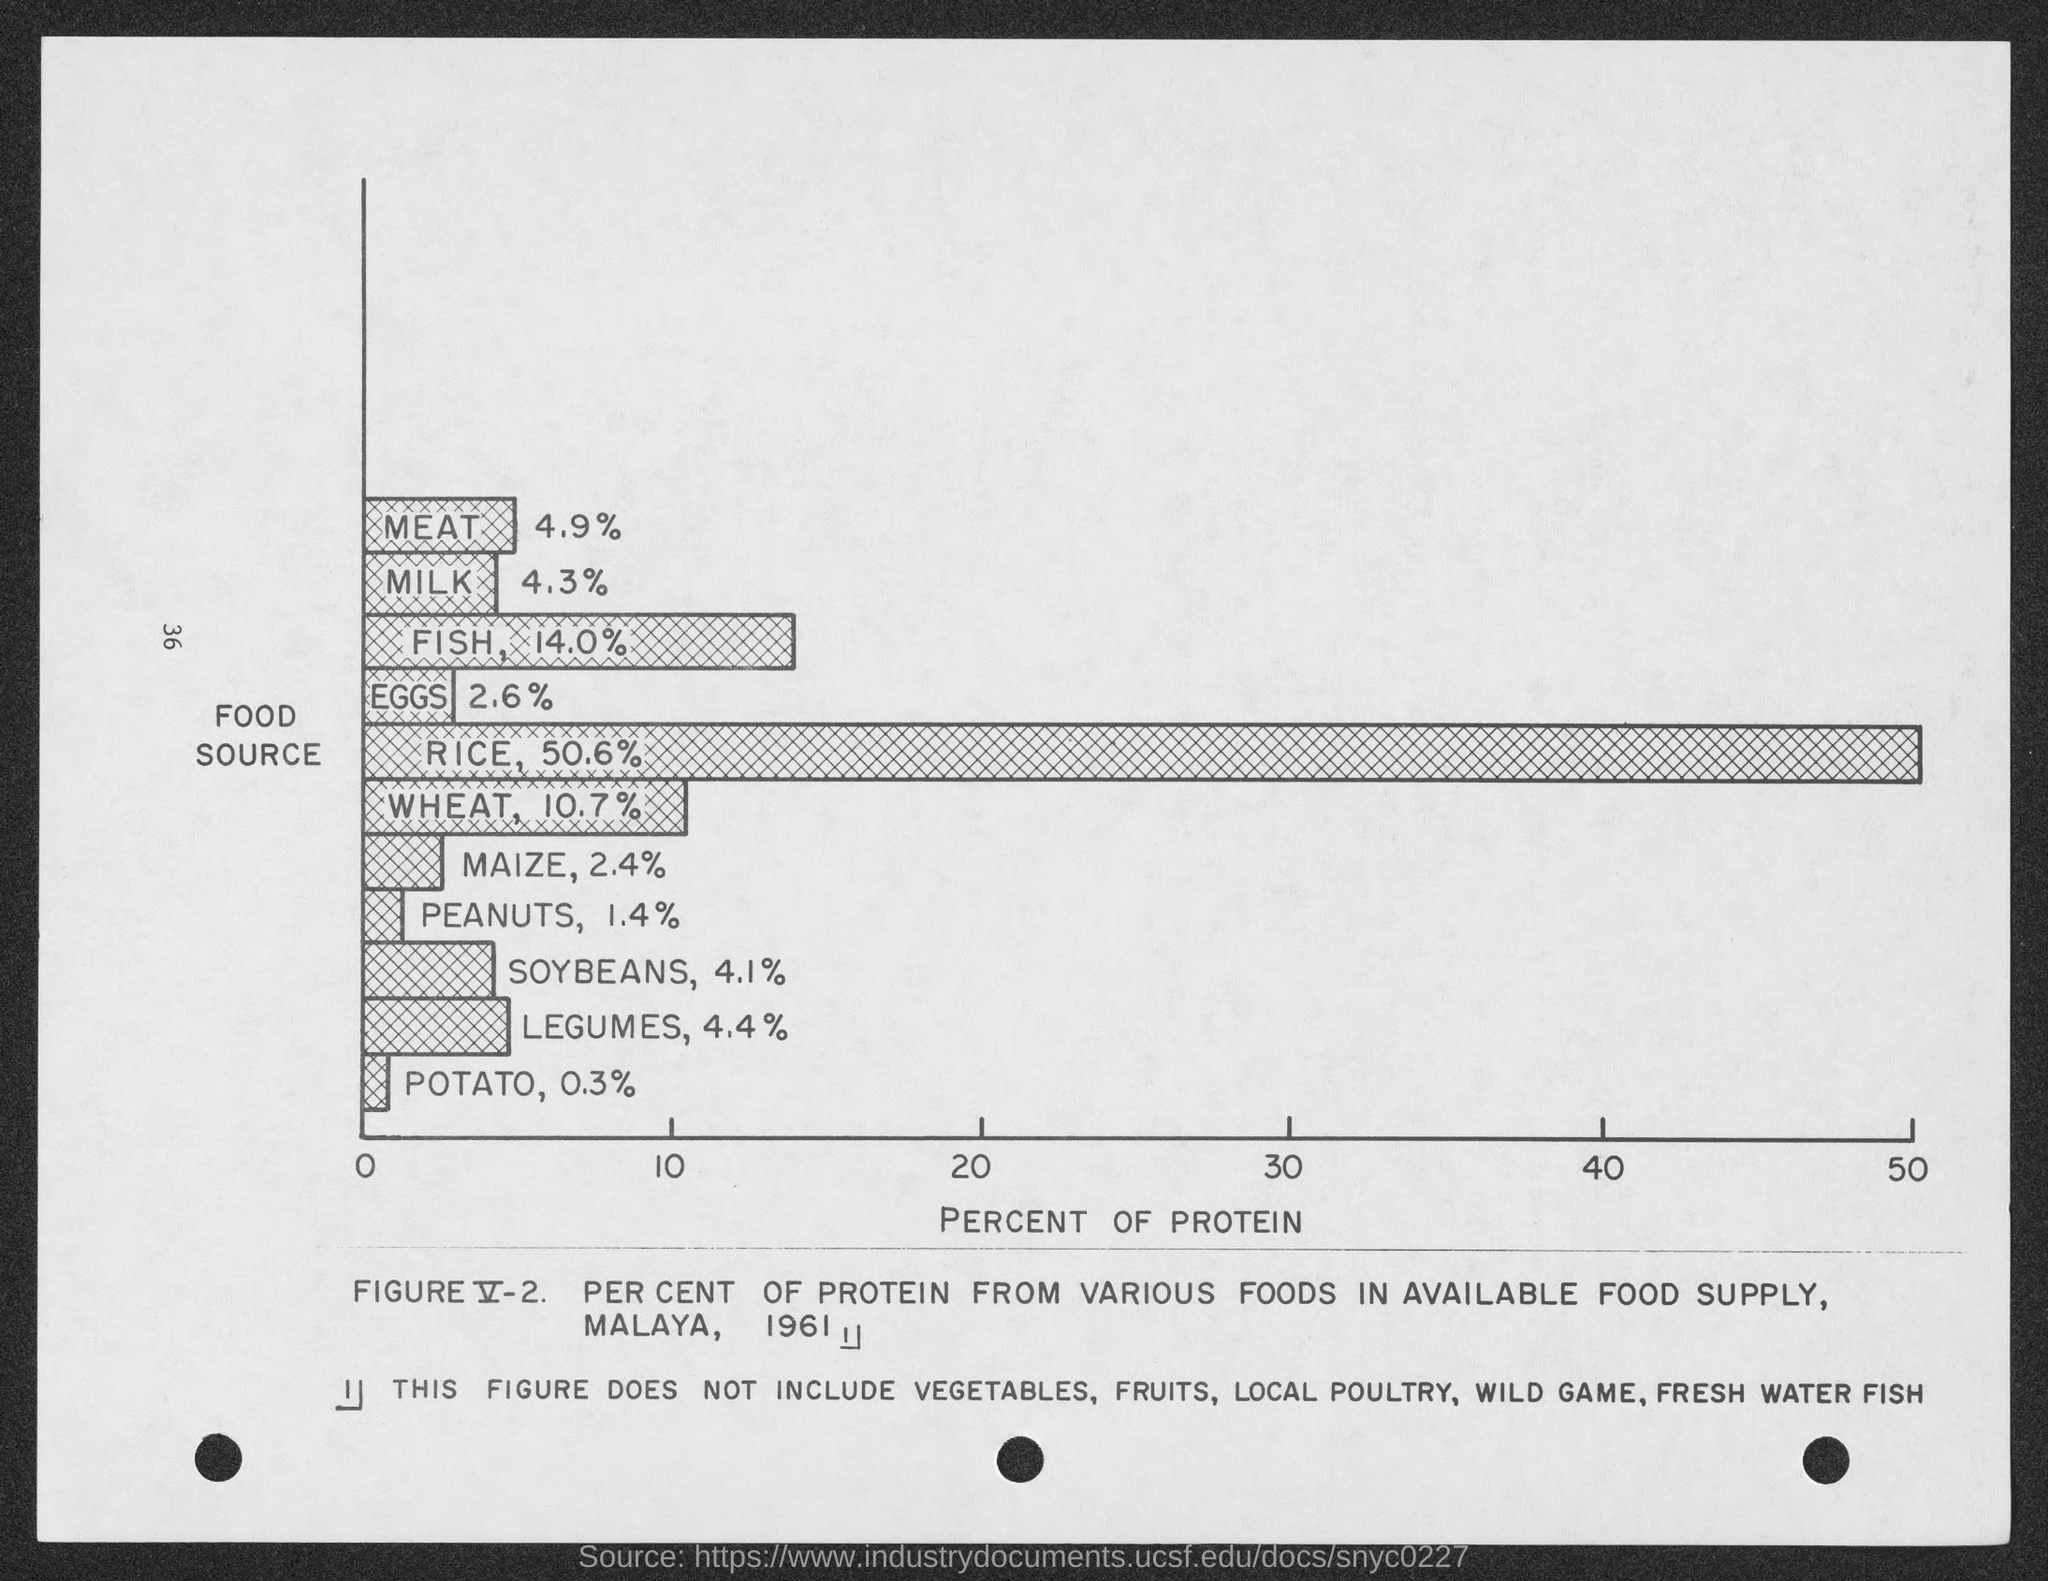What is the page number?
Your answer should be very brief. 36. What is on the x-axis?
Offer a very short reply. Percent of Protein. What is on the y-axis?
Your response must be concise. Food source. What is the percentage of protein in meat?
Your answer should be compact. 4.9%. Which food item has the highest percentage of protein?
Provide a short and direct response. Rice. Which food item has the least percentage of protein?
Your answer should be compact. Potato. Which food item has the second-highest percentage of protein?
Provide a succinct answer. Fish. Which food item has the second-lowest percentage of protein?
Give a very brief answer. Peanuts. The percentage of protein in rice?
Your response must be concise. 50.6%. The percentage of protein in maize?
Give a very brief answer. 2.4%. 